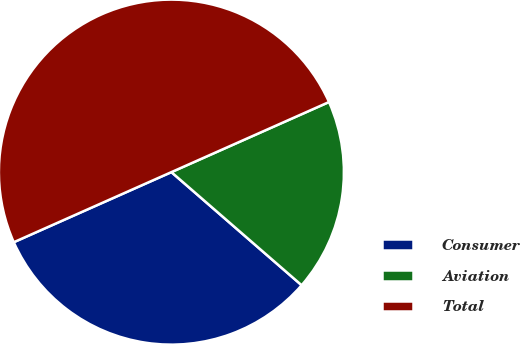<chart> <loc_0><loc_0><loc_500><loc_500><pie_chart><fcel>Consumer<fcel>Aviation<fcel>Total<nl><fcel>31.96%<fcel>18.04%<fcel>50.0%<nl></chart> 